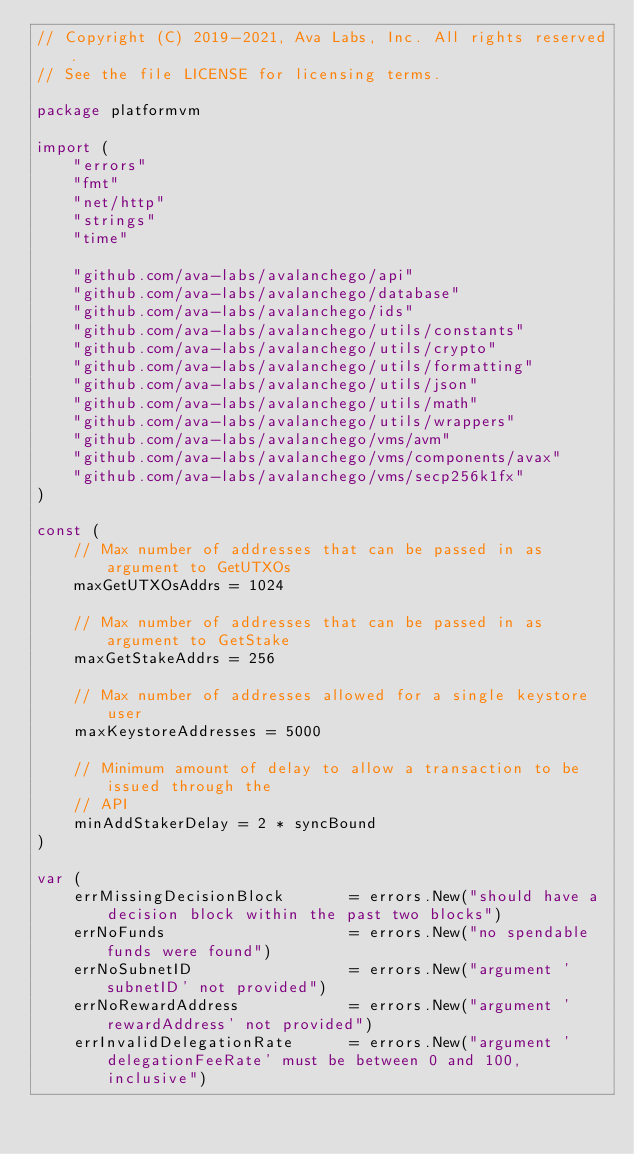<code> <loc_0><loc_0><loc_500><loc_500><_Go_>// Copyright (C) 2019-2021, Ava Labs, Inc. All rights reserved.
// See the file LICENSE for licensing terms.

package platformvm

import (
	"errors"
	"fmt"
	"net/http"
	"strings"
	"time"

	"github.com/ava-labs/avalanchego/api"
	"github.com/ava-labs/avalanchego/database"
	"github.com/ava-labs/avalanchego/ids"
	"github.com/ava-labs/avalanchego/utils/constants"
	"github.com/ava-labs/avalanchego/utils/crypto"
	"github.com/ava-labs/avalanchego/utils/formatting"
	"github.com/ava-labs/avalanchego/utils/json"
	"github.com/ava-labs/avalanchego/utils/math"
	"github.com/ava-labs/avalanchego/utils/wrappers"
	"github.com/ava-labs/avalanchego/vms/avm"
	"github.com/ava-labs/avalanchego/vms/components/avax"
	"github.com/ava-labs/avalanchego/vms/secp256k1fx"
)

const (
	// Max number of addresses that can be passed in as argument to GetUTXOs
	maxGetUTXOsAddrs = 1024

	// Max number of addresses that can be passed in as argument to GetStake
	maxGetStakeAddrs = 256

	// Max number of addresses allowed for a single keystore user
	maxKeystoreAddresses = 5000

	// Minimum amount of delay to allow a transaction to be issued through the
	// API
	minAddStakerDelay = 2 * syncBound
)

var (
	errMissingDecisionBlock       = errors.New("should have a decision block within the past two blocks")
	errNoFunds                    = errors.New("no spendable funds were found")
	errNoSubnetID                 = errors.New("argument 'subnetID' not provided")
	errNoRewardAddress            = errors.New("argument 'rewardAddress' not provided")
	errInvalidDelegationRate      = errors.New("argument 'delegationFeeRate' must be between 0 and 100, inclusive")</code> 